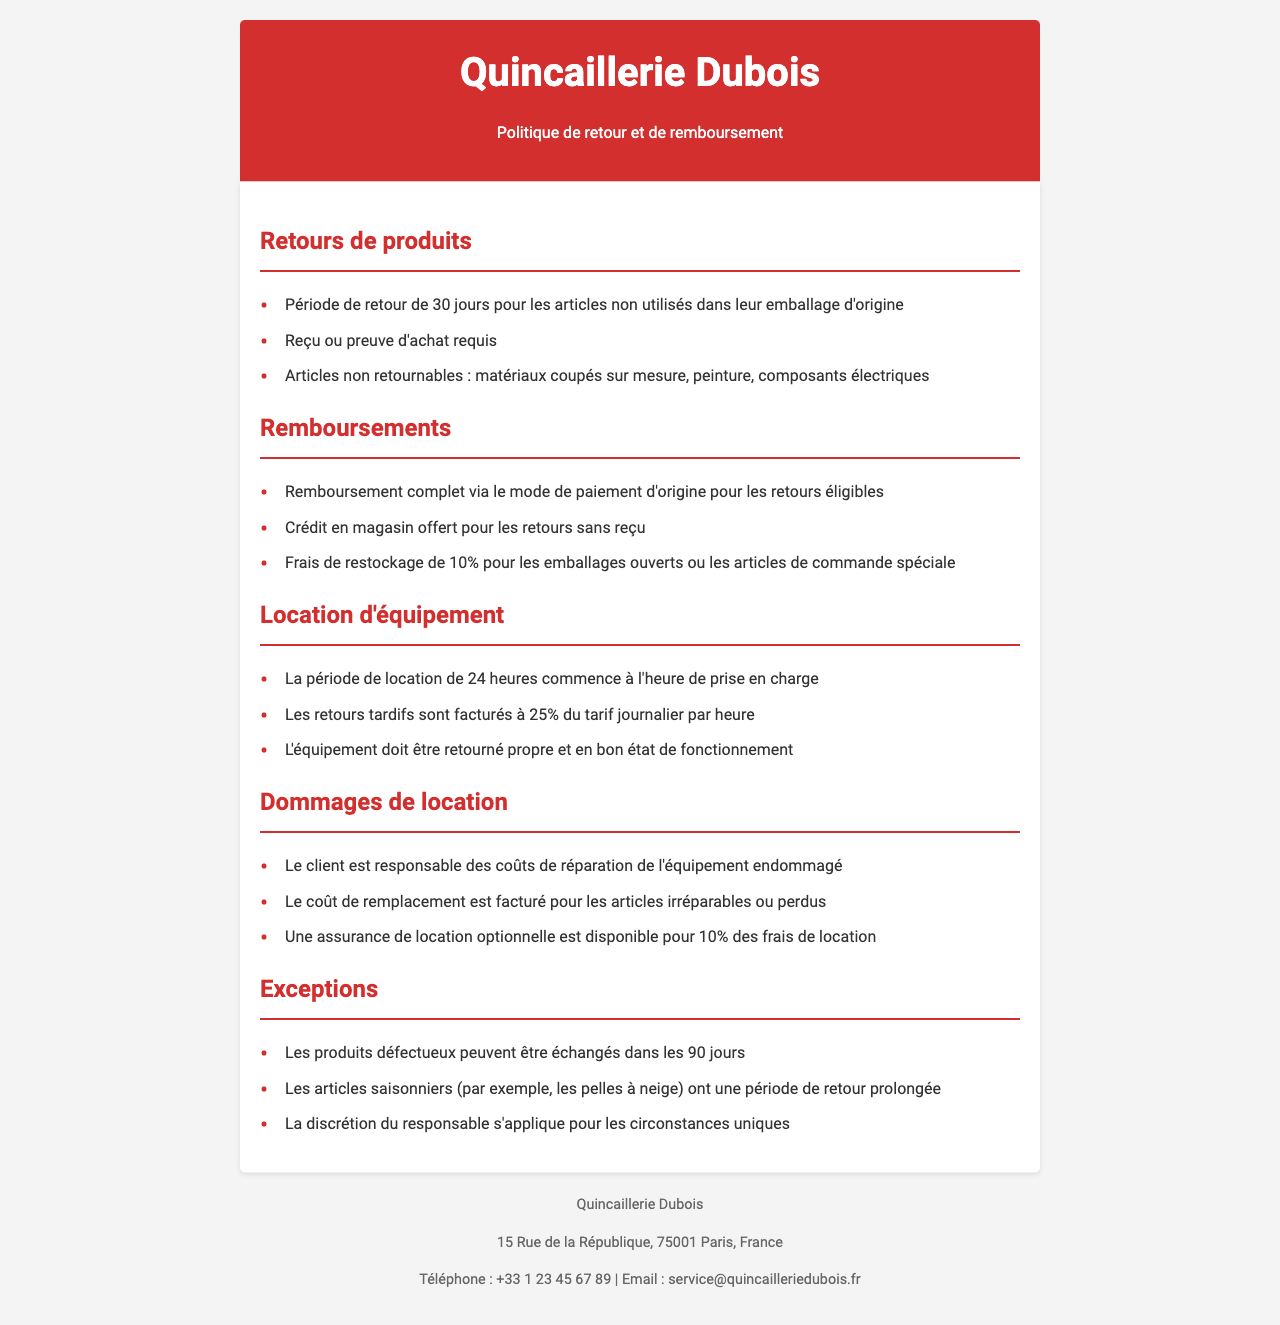Quelle est la période de retour pour les articles non utilisés ? La période de retour pour les articles non utilisés est mentionnée dans la section "Retours de produits".
Answer: 30 jours Quelles sont les conditions requises pour un retour ? Les conditions requises pour un retour se trouvent dans la section "Retours de produits".
Answer: Reçu ou preuve d'achat requis Quels articles ne peuvent pas être retournés ? Les articles non retournables sont listés dans la section "Retours de produits".
Answer: Matériaux coupés sur mesure, peinture, composants électriques Quel pourcentage est facturé pour les retours d'articles ouverts ? Ce pourcentage est donné dans la section "Remboursements".
Answer: 10% Quel est le tarif pour les retours tardifs d'équipement loué ? Le tarif pour les retours tardifs est précisé dans la section "Location d'équipement".
Answer: 25% du tarif journalier par heure Responsabilité en cas de dommage sur l'équipement loué ? La responsabilité concernant les dommages est mentionnée dans la section "Dommages de location".
Answer: Le client est responsable des coûts de réparation Quelle est la période d'échange pour les produits défectueux ? La période d'échange pour les produits défectueux est indiquée dans la section "Exceptions".
Answer: 90 jours Quel type d'articles a une période de retour prolongée ? Le type d'articles avec une période de retour prolongée est spécifié dans la section "Exceptions".
Answer: Articles saisonniers Quelle option d'assurance est disponible pour la location ? L'option d'assurance est décrite dans la section "Dommages de location".
Answer: Assurance de location optionnelle pour 10% des frais de location 